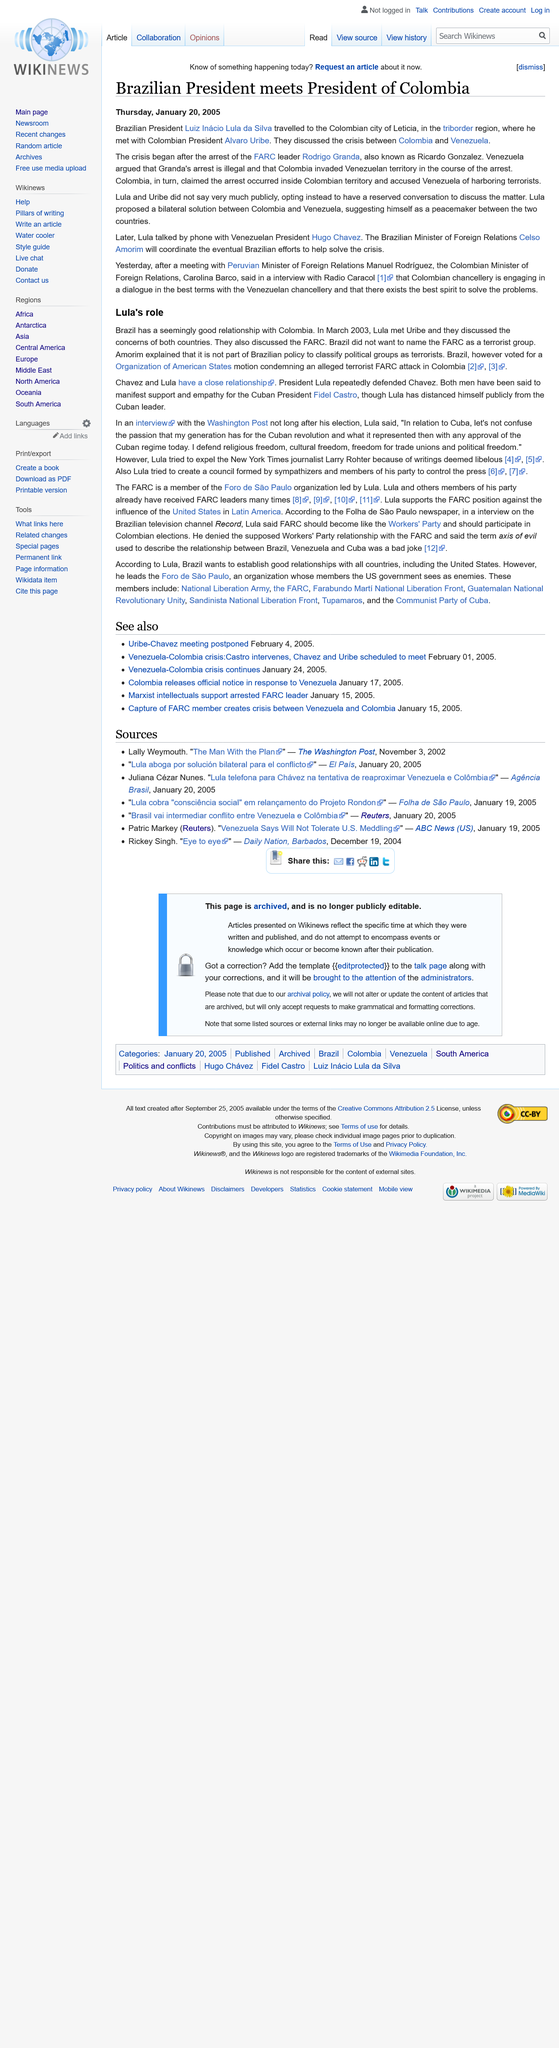Indicate a few pertinent items in this graphic. It can be stated as: "Larry Rohter is employed by the New York Times. The meeting between Lula and Uribe to discuss FARC took place in March 2003. Hugo Chavez is the President of Venezuela, making him the leader of the country. The article mentions Cuba, Columbia, and Brazil. The article was published on Thursday January 20th 2005. 